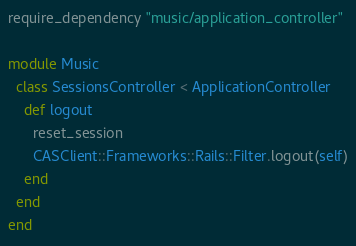<code> <loc_0><loc_0><loc_500><loc_500><_Ruby_>require_dependency "music/application_controller"

module Music
  class SessionsController < ApplicationController
    def logout
      reset_session
      CASClient::Frameworks::Rails::Filter.logout(self)
    end
  end
end
</code> 